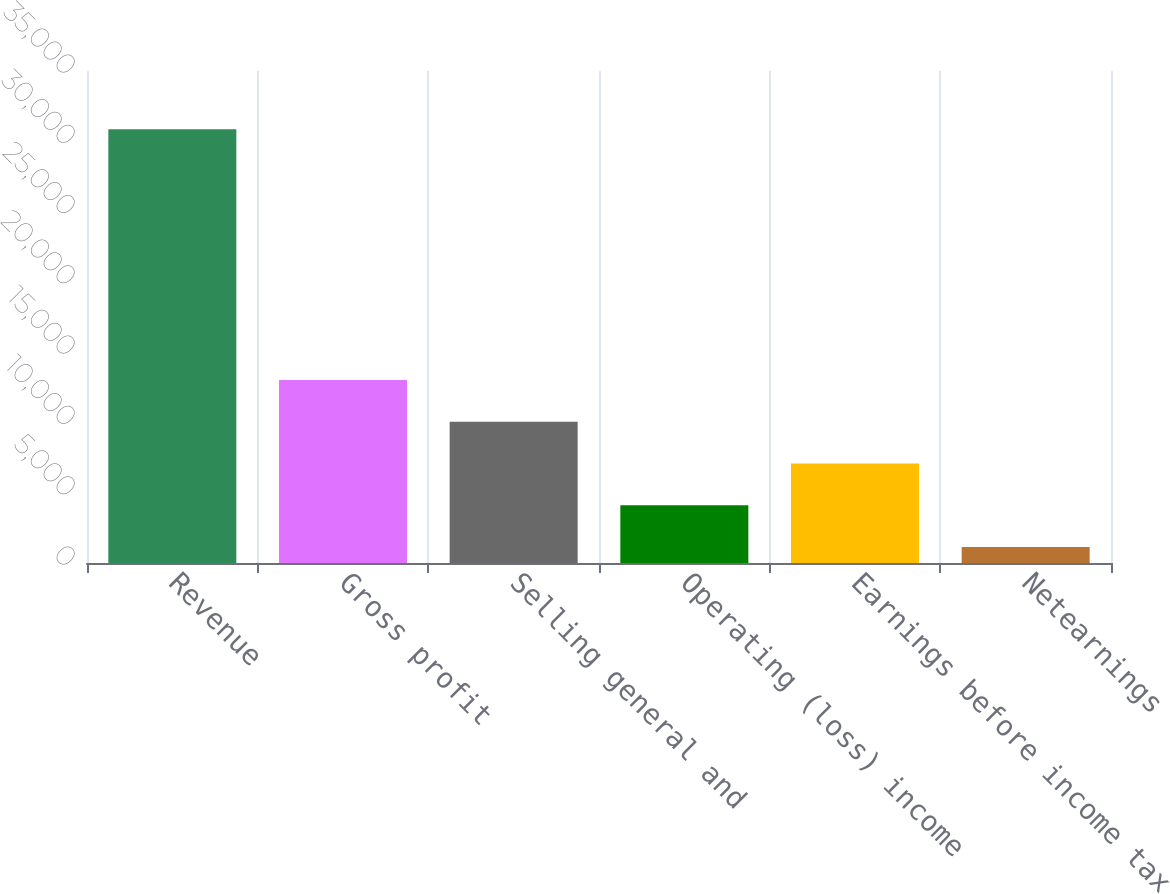<chart> <loc_0><loc_0><loc_500><loc_500><bar_chart><fcel>Revenue<fcel>Gross profit<fcel>Selling general and<fcel>Operating (loss) income<fcel>Earnings before income tax<fcel>Netearnings<nl><fcel>30848<fcel>13023.2<fcel>10052.4<fcel>4110.8<fcel>7081.6<fcel>1140<nl></chart> 